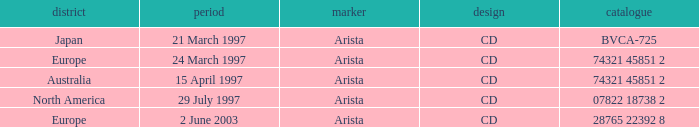What's listed for the Label with a Date of 29 July 1997? Arista. 